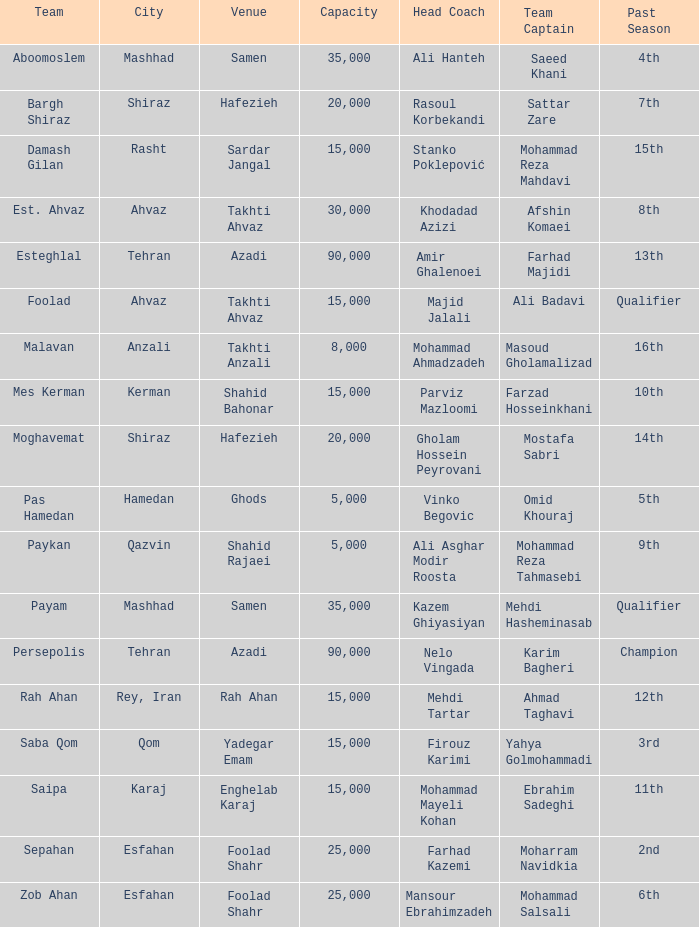What is the maximum occupancy of the venue where head coach farhad kazemi's events take place? 25000.0. 